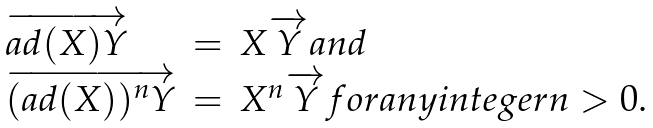<formula> <loc_0><loc_0><loc_500><loc_500>\begin{array} { l l l } \overrightarrow { a d ( X ) Y } & = & X \overrightarrow { Y } a n d \\ \overrightarrow { ( a d ( X ) ) ^ { n } Y } & = & X ^ { n } \overrightarrow { Y } f o r a n y i n t e g e r n > 0 . \\ \end{array}</formula> 